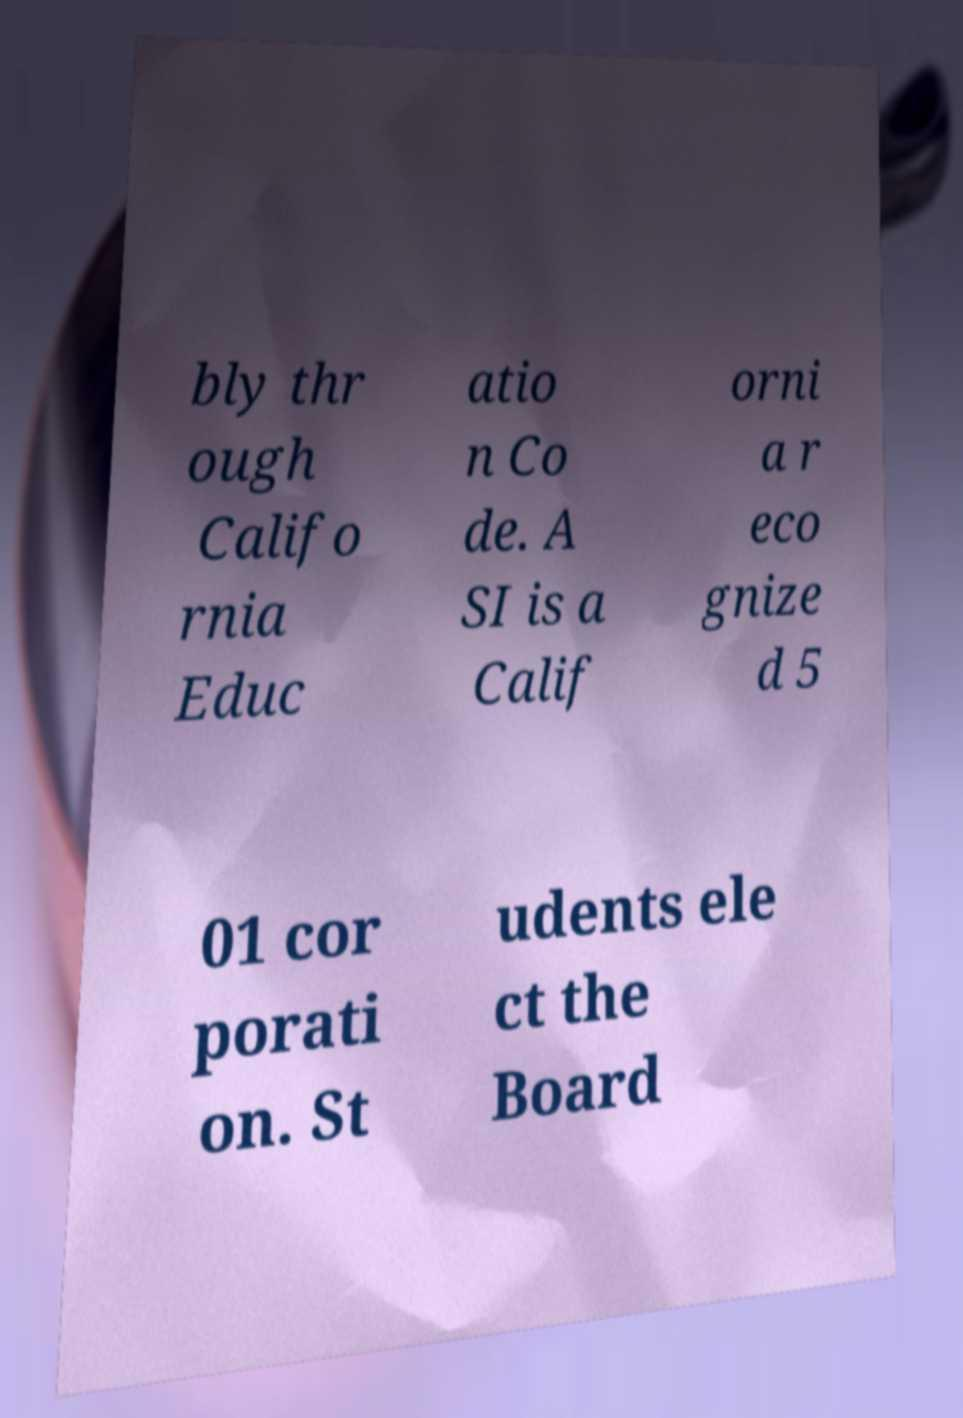Could you assist in decoding the text presented in this image and type it out clearly? bly thr ough Califo rnia Educ atio n Co de. A SI is a Calif orni a r eco gnize d 5 01 cor porati on. St udents ele ct the Board 